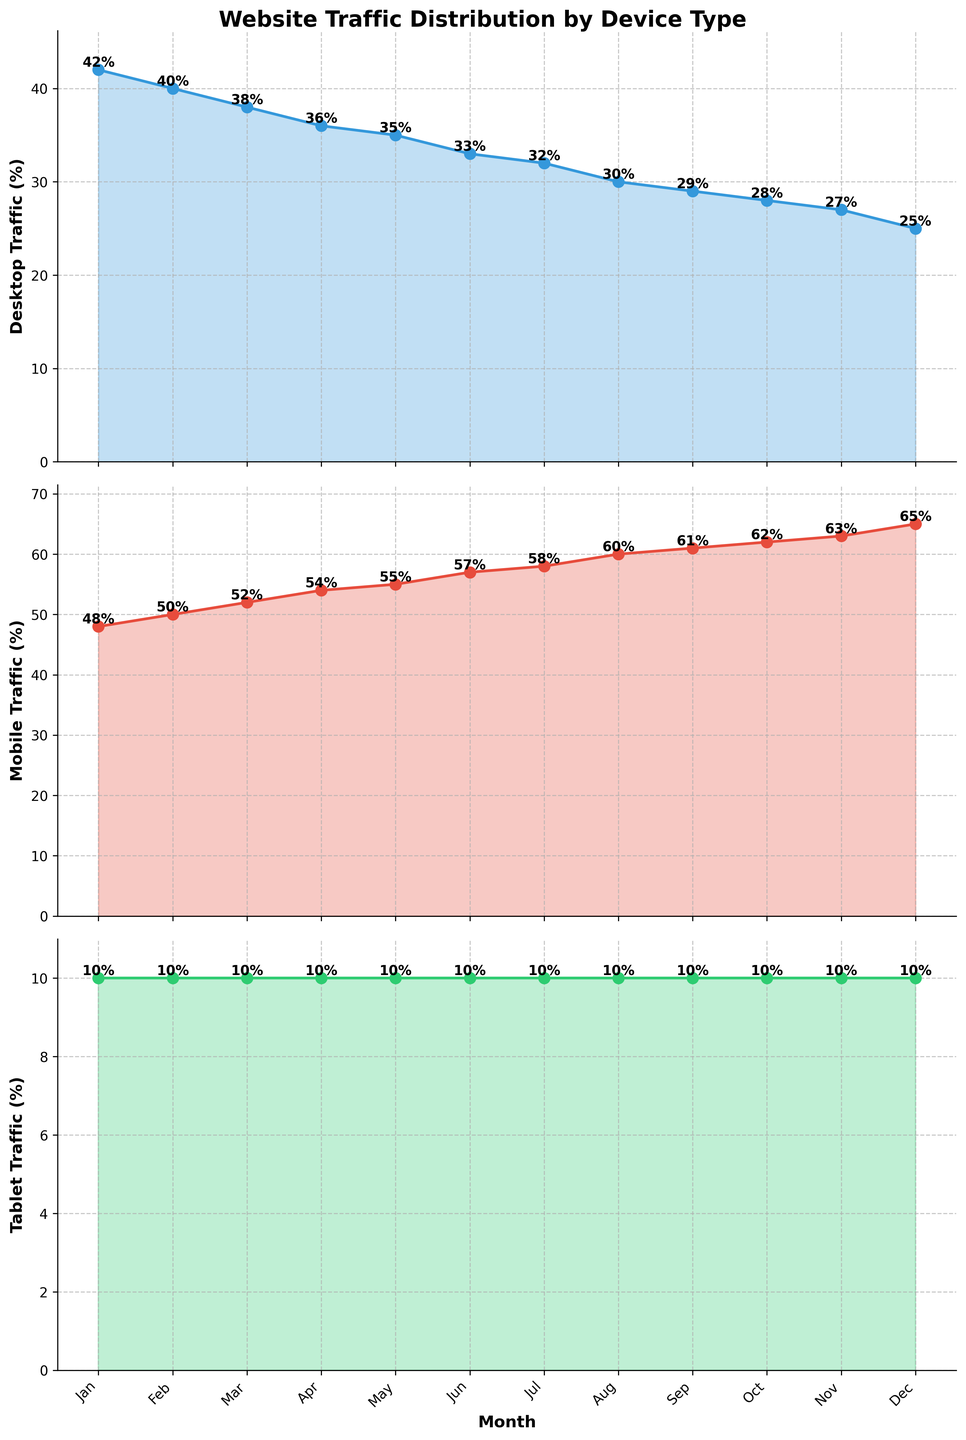What is the trend of Desktop traffic throughout the year? The Desktop traffic shows a decreasing trend. Starting from 42% in January and gradually declining to 25% in December.
Answer: Decreasing How does the Mobile traffic percentage in July compare to the Desktop traffic percentage in the same month? In July, the Mobile traffic is at 58%, while the Desktop traffic is at 32%. Therefore, Mobile traffic is higher than Desktop traffic by 26 percentage points.
Answer: Mobile traffic is 26% higher What is the average traffic percentage for Tablet over the year? The traffic percentage for Tablet is constant at 10% for every month. The average across the year would be the same, which is 10%.
Answer: 10% Which month shows the highest proportion of Mobile traffic? By examining the Mobile traffic subplot, December has the highest Mobile traffic proportion at 65%.
Answer: December In which month does Desktop traffic drop below 30%? Observing the Desktop traffic subplot, Desktop traffic drops below 30% in September, when it is at 29%.
Answer: September By what percentage does Desktop traffic decrease from January to December? Desktop traffic decreases from 42% in January to 25% in December. The percentage decrease is calculated as (42% - 25%) / 42% * 100%, which equals approximately 40.48%.
Answer: 40.48% What is the median value of Mobile traffic over the year? The monthly Mobile traffic percentages over the year are: 48, 50, 52, 54, 55, 57, 58, 60, 61, 62, 63, 65. To find the median, list the values in ascending order. The two middle values are 57 and 58, so the median is (57 + 58) / 2 = 57.5%.
Answer: 57.5% What color represents Tablet traffic in the plot? The color filling and line for the Tablet traffic are in green.
Answer: Green 